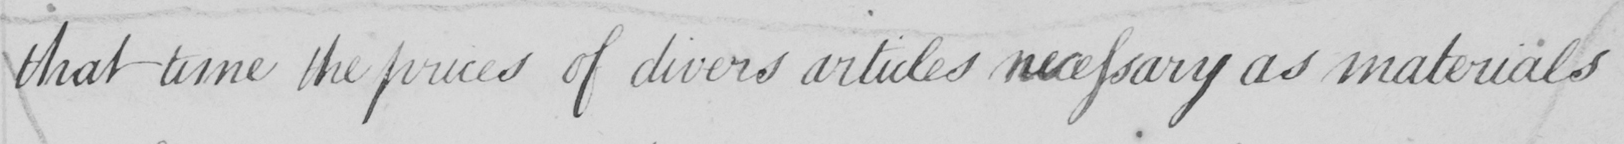What is written in this line of handwriting? That time the prices of divers articles necessary as materials 